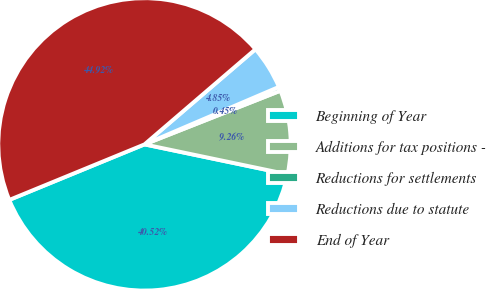<chart> <loc_0><loc_0><loc_500><loc_500><pie_chart><fcel>Beginning of Year<fcel>Additions for tax positions -<fcel>Reductions for settlements<fcel>Reductions due to statute<fcel>End of Year<nl><fcel>40.52%<fcel>9.26%<fcel>0.45%<fcel>4.85%<fcel>44.92%<nl></chart> 